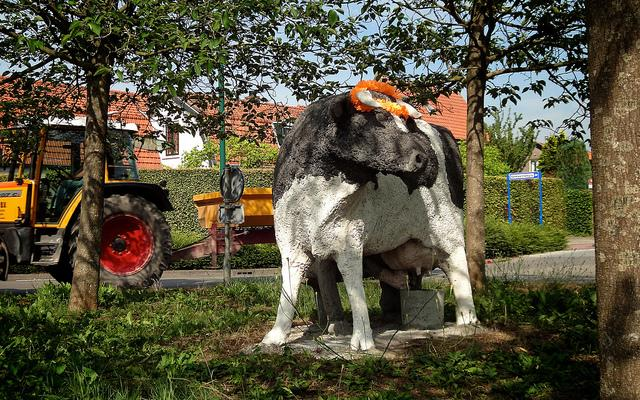What feature of the animal is visible? cow 